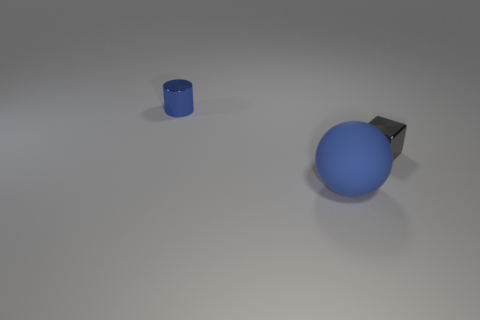Is there a cylinder of the same color as the rubber object?
Your answer should be compact. Yes. What is the size of the blue object that is behind the gray cube to the right of the big thing?
Offer a terse response. Small. There is a object that is both left of the tiny gray metal thing and to the right of the tiny shiny cylinder; what is its size?
Give a very brief answer. Large. How many gray things have the same size as the blue metal object?
Keep it short and to the point. 1. What number of metal things are either balls or tiny brown objects?
Your answer should be compact. 0. The other object that is the same color as the big thing is what size?
Give a very brief answer. Small. The tiny thing behind the shiny thing to the right of the large blue matte sphere is made of what material?
Make the answer very short. Metal. What number of objects are small cylinders or tiny objects that are on the right side of the cylinder?
Ensure brevity in your answer.  2. What size is the other object that is the same material as the small gray thing?
Your response must be concise. Small. How many gray things are tiny rubber objects or cylinders?
Your answer should be compact. 0. 